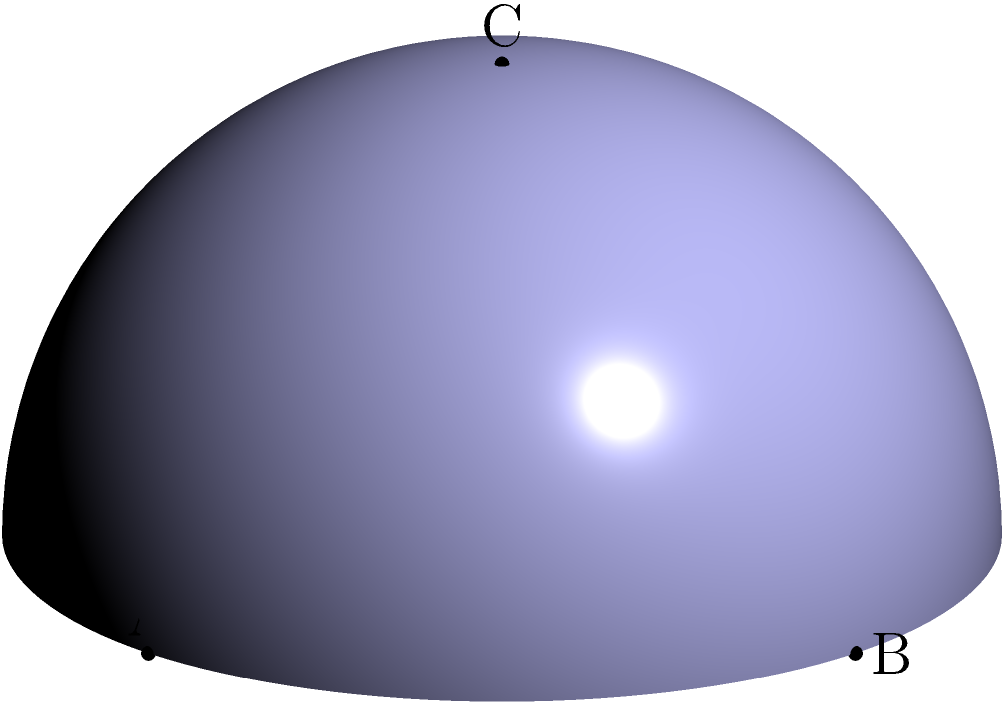In your resort's new geodesic dome-shaped event space, you've noticed that the triangular panels don't seem to follow the usual rules of geometry. If you were to measure the angles of the triangle formed by connecting the points A, B, and C on the surface of this dome, what would be special about the sum of these angles compared to a triangle on a flat surface? Let's approach this step-by-step:

1) In Euclidean (flat) geometry, the sum of angles in a triangle is always 180°.

2) However, the surface of a dome is not flat - it's a curved surface, similar to a portion of a sphere. This type of geometry is called spherical geometry.

3) In spherical geometry, triangles behave differently:
   - The sides of the triangle are actually arcs of great circles on the sphere.
   - The angles are measured between these great circle arcs.

4) A key property of spherical triangles is that the sum of their angles is always greater than 180°.

5) The excess above 180° is proportional to the area of the triangle on the sphere's surface.

6) In the extreme case, consider the triangle formed by two longitudinal lines meeting at the poles and the equator. Each angle is 90°, summing to 270°.

7) The triangle ABC shown in the diagram is a special case known as a "tri-rectangular" spherical triangle, where all three angles are right angles (90°).

8) Therefore, the sum of angles in this spherical triangle is:

   $$ 90° + 90° + 90° = 270° $$

This is 90° more than what you'd expect in a flat triangle.
Answer: The sum of angles exceeds 180°, specifically totaling 270°. 